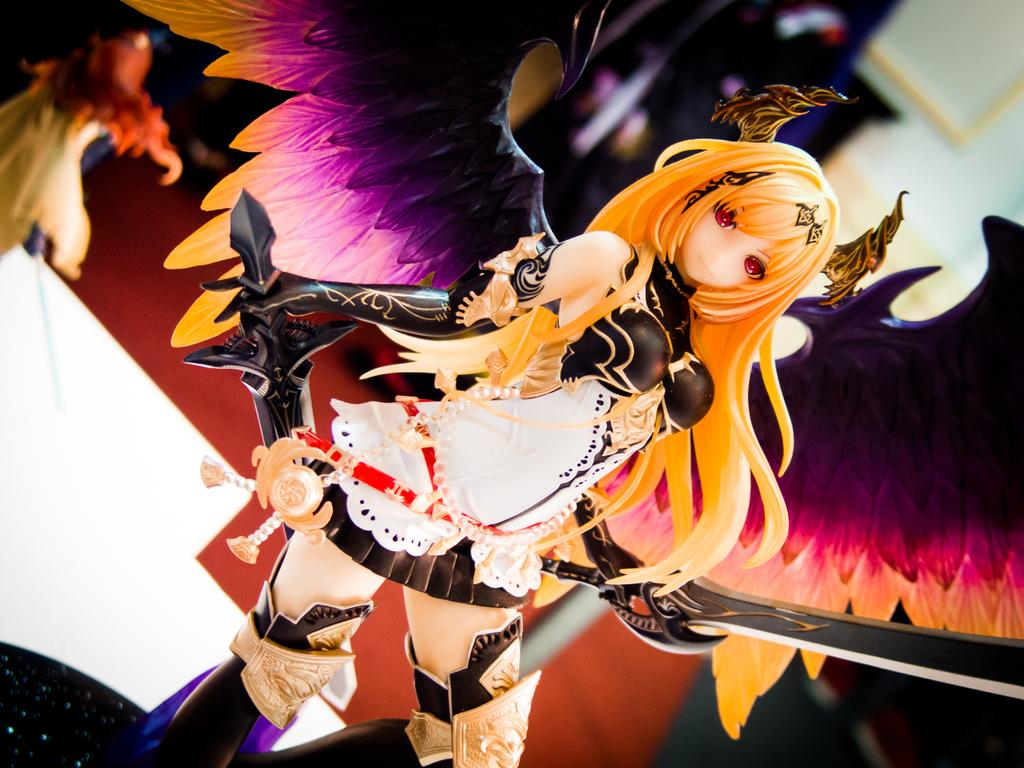What type of object is in the image? There is a toy in the image. What feature does the toy have? The toy has wings. What is the toy holding? The toy is holding swords. Can you describe the background of the image? The background of the image is blurred. What type of tramp can be seen in the image? There is no tramp present in the image; it features a toy with wings and swords. What is the name of the son in the image? There is no son present in the image; it features a toy with wings and swords. 